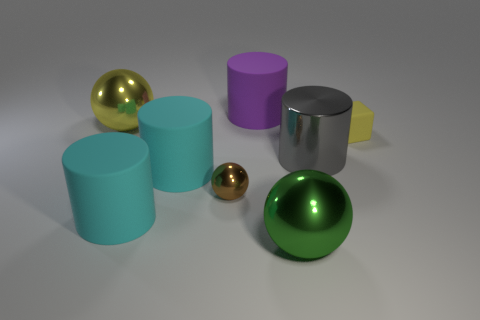Does the cylinder that is right of the large purple cylinder have the same size as the cylinder behind the big metallic cylinder?
Keep it short and to the point. Yes. What is the material of the sphere that is right of the big yellow sphere and behind the green sphere?
Provide a succinct answer. Metal. Is the number of rubber cubes less than the number of large gray rubber cubes?
Your answer should be very brief. No. There is a rubber object that is to the right of the green thing that is left of the gray metallic cylinder; what is its size?
Offer a terse response. Small. What shape is the object that is behind the sphere on the left side of the brown shiny ball that is in front of the small rubber cube?
Give a very brief answer. Cylinder. There is a big cylinder that is the same material as the tiny sphere; what color is it?
Provide a short and direct response. Gray. What is the color of the big rubber cylinder behind the big shiny sphere behind the object that is to the right of the gray object?
Provide a succinct answer. Purple. How many balls are either matte things or tiny brown metallic things?
Offer a very short reply. 1. There is a large ball that is the same color as the tiny matte thing; what material is it?
Offer a very short reply. Metal. Do the rubber block and the big metal ball that is behind the small yellow matte object have the same color?
Make the answer very short. Yes. 